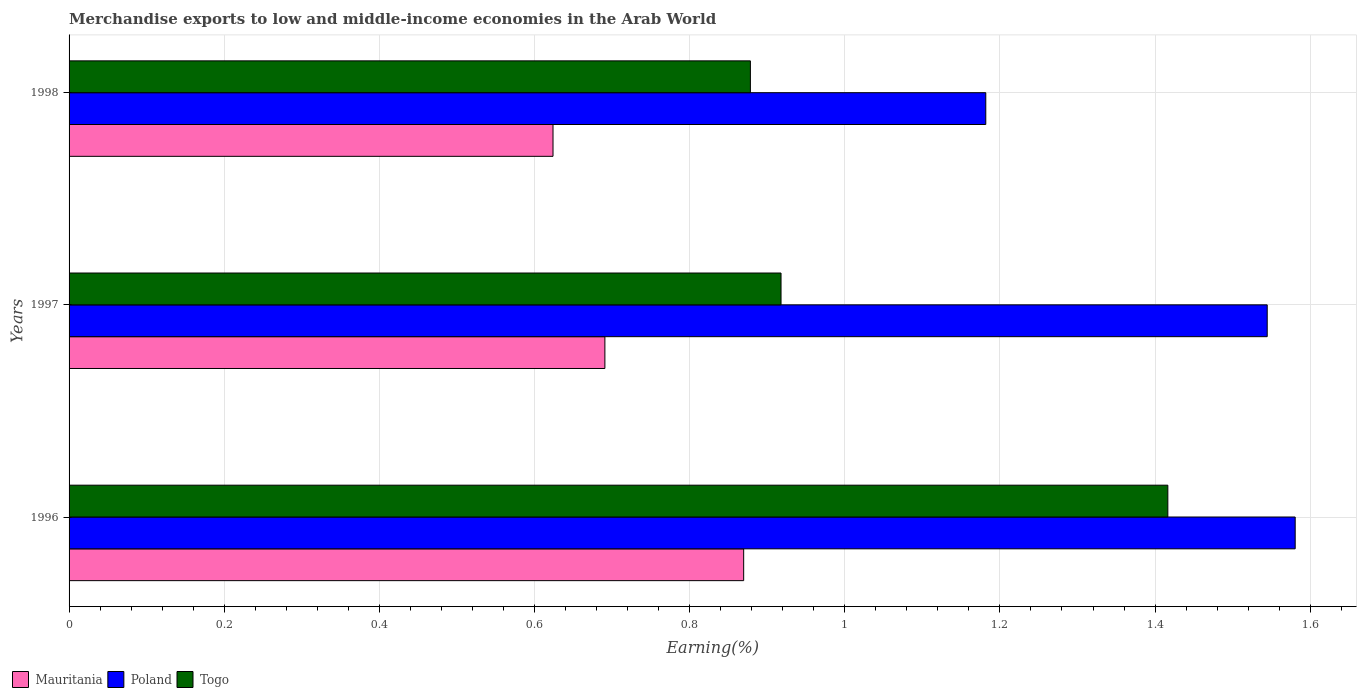How many different coloured bars are there?
Provide a succinct answer. 3. Are the number of bars on each tick of the Y-axis equal?
Provide a succinct answer. Yes. How many bars are there on the 3rd tick from the bottom?
Provide a succinct answer. 3. In how many cases, is the number of bars for a given year not equal to the number of legend labels?
Offer a very short reply. 0. What is the percentage of amount earned from merchandise exports in Mauritania in 1998?
Your response must be concise. 0.62. Across all years, what is the maximum percentage of amount earned from merchandise exports in Mauritania?
Keep it short and to the point. 0.87. Across all years, what is the minimum percentage of amount earned from merchandise exports in Togo?
Keep it short and to the point. 0.88. In which year was the percentage of amount earned from merchandise exports in Mauritania minimum?
Provide a succinct answer. 1998. What is the total percentage of amount earned from merchandise exports in Mauritania in the graph?
Provide a succinct answer. 2.18. What is the difference between the percentage of amount earned from merchandise exports in Mauritania in 1997 and that in 1998?
Provide a short and direct response. 0.07. What is the difference between the percentage of amount earned from merchandise exports in Mauritania in 1996 and the percentage of amount earned from merchandise exports in Poland in 1998?
Keep it short and to the point. -0.31. What is the average percentage of amount earned from merchandise exports in Poland per year?
Provide a succinct answer. 1.44. In the year 1996, what is the difference between the percentage of amount earned from merchandise exports in Togo and percentage of amount earned from merchandise exports in Mauritania?
Offer a very short reply. 0.55. What is the ratio of the percentage of amount earned from merchandise exports in Togo in 1996 to that in 1997?
Offer a very short reply. 1.54. Is the difference between the percentage of amount earned from merchandise exports in Togo in 1997 and 1998 greater than the difference between the percentage of amount earned from merchandise exports in Mauritania in 1997 and 1998?
Ensure brevity in your answer.  No. What is the difference between the highest and the second highest percentage of amount earned from merchandise exports in Poland?
Offer a terse response. 0.04. What is the difference between the highest and the lowest percentage of amount earned from merchandise exports in Mauritania?
Your answer should be very brief. 0.25. In how many years, is the percentage of amount earned from merchandise exports in Mauritania greater than the average percentage of amount earned from merchandise exports in Mauritania taken over all years?
Make the answer very short. 1. What does the 3rd bar from the top in 1998 represents?
Your answer should be compact. Mauritania. What does the 3rd bar from the bottom in 1998 represents?
Your answer should be very brief. Togo. Is it the case that in every year, the sum of the percentage of amount earned from merchandise exports in Poland and percentage of amount earned from merchandise exports in Mauritania is greater than the percentage of amount earned from merchandise exports in Togo?
Give a very brief answer. Yes. Does the graph contain grids?
Give a very brief answer. Yes. How many legend labels are there?
Your answer should be compact. 3. How are the legend labels stacked?
Offer a very short reply. Horizontal. What is the title of the graph?
Offer a very short reply. Merchandise exports to low and middle-income economies in the Arab World. What is the label or title of the X-axis?
Give a very brief answer. Earning(%). What is the Earning(%) of Mauritania in 1996?
Your answer should be very brief. 0.87. What is the Earning(%) of Poland in 1996?
Offer a terse response. 1.58. What is the Earning(%) of Togo in 1996?
Give a very brief answer. 1.42. What is the Earning(%) of Mauritania in 1997?
Your response must be concise. 0.69. What is the Earning(%) in Poland in 1997?
Make the answer very short. 1.54. What is the Earning(%) in Togo in 1997?
Offer a very short reply. 0.92. What is the Earning(%) in Mauritania in 1998?
Provide a short and direct response. 0.62. What is the Earning(%) in Poland in 1998?
Your response must be concise. 1.18. What is the Earning(%) in Togo in 1998?
Give a very brief answer. 0.88. Across all years, what is the maximum Earning(%) of Mauritania?
Make the answer very short. 0.87. Across all years, what is the maximum Earning(%) in Poland?
Offer a terse response. 1.58. Across all years, what is the maximum Earning(%) in Togo?
Keep it short and to the point. 1.42. Across all years, what is the minimum Earning(%) in Mauritania?
Your answer should be very brief. 0.62. Across all years, what is the minimum Earning(%) in Poland?
Offer a terse response. 1.18. Across all years, what is the minimum Earning(%) in Togo?
Give a very brief answer. 0.88. What is the total Earning(%) of Mauritania in the graph?
Offer a terse response. 2.18. What is the total Earning(%) of Poland in the graph?
Keep it short and to the point. 4.31. What is the total Earning(%) in Togo in the graph?
Provide a succinct answer. 3.21. What is the difference between the Earning(%) in Mauritania in 1996 and that in 1997?
Your answer should be compact. 0.18. What is the difference between the Earning(%) in Poland in 1996 and that in 1997?
Your answer should be compact. 0.04. What is the difference between the Earning(%) of Togo in 1996 and that in 1997?
Provide a short and direct response. 0.5. What is the difference between the Earning(%) in Mauritania in 1996 and that in 1998?
Provide a succinct answer. 0.25. What is the difference between the Earning(%) of Poland in 1996 and that in 1998?
Keep it short and to the point. 0.4. What is the difference between the Earning(%) of Togo in 1996 and that in 1998?
Your response must be concise. 0.54. What is the difference between the Earning(%) of Mauritania in 1997 and that in 1998?
Offer a very short reply. 0.07. What is the difference between the Earning(%) in Poland in 1997 and that in 1998?
Give a very brief answer. 0.36. What is the difference between the Earning(%) in Togo in 1997 and that in 1998?
Your answer should be very brief. 0.04. What is the difference between the Earning(%) of Mauritania in 1996 and the Earning(%) of Poland in 1997?
Provide a succinct answer. -0.67. What is the difference between the Earning(%) of Mauritania in 1996 and the Earning(%) of Togo in 1997?
Offer a terse response. -0.05. What is the difference between the Earning(%) of Poland in 1996 and the Earning(%) of Togo in 1997?
Keep it short and to the point. 0.66. What is the difference between the Earning(%) of Mauritania in 1996 and the Earning(%) of Poland in 1998?
Your answer should be compact. -0.31. What is the difference between the Earning(%) in Mauritania in 1996 and the Earning(%) in Togo in 1998?
Offer a very short reply. -0.01. What is the difference between the Earning(%) in Poland in 1996 and the Earning(%) in Togo in 1998?
Offer a very short reply. 0.7. What is the difference between the Earning(%) in Mauritania in 1997 and the Earning(%) in Poland in 1998?
Give a very brief answer. -0.49. What is the difference between the Earning(%) of Mauritania in 1997 and the Earning(%) of Togo in 1998?
Provide a succinct answer. -0.19. What is the difference between the Earning(%) of Poland in 1997 and the Earning(%) of Togo in 1998?
Provide a succinct answer. 0.67. What is the average Earning(%) of Mauritania per year?
Your answer should be compact. 0.73. What is the average Earning(%) in Poland per year?
Your answer should be compact. 1.44. What is the average Earning(%) of Togo per year?
Your response must be concise. 1.07. In the year 1996, what is the difference between the Earning(%) in Mauritania and Earning(%) in Poland?
Provide a succinct answer. -0.71. In the year 1996, what is the difference between the Earning(%) of Mauritania and Earning(%) of Togo?
Ensure brevity in your answer.  -0.55. In the year 1996, what is the difference between the Earning(%) of Poland and Earning(%) of Togo?
Your answer should be compact. 0.16. In the year 1997, what is the difference between the Earning(%) in Mauritania and Earning(%) in Poland?
Provide a succinct answer. -0.85. In the year 1997, what is the difference between the Earning(%) in Mauritania and Earning(%) in Togo?
Offer a terse response. -0.23. In the year 1997, what is the difference between the Earning(%) in Poland and Earning(%) in Togo?
Offer a very short reply. 0.63. In the year 1998, what is the difference between the Earning(%) of Mauritania and Earning(%) of Poland?
Your response must be concise. -0.56. In the year 1998, what is the difference between the Earning(%) in Mauritania and Earning(%) in Togo?
Keep it short and to the point. -0.25. In the year 1998, what is the difference between the Earning(%) of Poland and Earning(%) of Togo?
Make the answer very short. 0.3. What is the ratio of the Earning(%) of Mauritania in 1996 to that in 1997?
Make the answer very short. 1.26. What is the ratio of the Earning(%) in Poland in 1996 to that in 1997?
Offer a terse response. 1.02. What is the ratio of the Earning(%) in Togo in 1996 to that in 1997?
Your answer should be very brief. 1.54. What is the ratio of the Earning(%) in Mauritania in 1996 to that in 1998?
Give a very brief answer. 1.39. What is the ratio of the Earning(%) in Poland in 1996 to that in 1998?
Offer a terse response. 1.34. What is the ratio of the Earning(%) in Togo in 1996 to that in 1998?
Your response must be concise. 1.61. What is the ratio of the Earning(%) of Mauritania in 1997 to that in 1998?
Offer a very short reply. 1.11. What is the ratio of the Earning(%) in Poland in 1997 to that in 1998?
Give a very brief answer. 1.31. What is the ratio of the Earning(%) of Togo in 1997 to that in 1998?
Keep it short and to the point. 1.04. What is the difference between the highest and the second highest Earning(%) in Mauritania?
Ensure brevity in your answer.  0.18. What is the difference between the highest and the second highest Earning(%) in Poland?
Ensure brevity in your answer.  0.04. What is the difference between the highest and the second highest Earning(%) in Togo?
Offer a very short reply. 0.5. What is the difference between the highest and the lowest Earning(%) in Mauritania?
Provide a short and direct response. 0.25. What is the difference between the highest and the lowest Earning(%) of Poland?
Make the answer very short. 0.4. What is the difference between the highest and the lowest Earning(%) of Togo?
Ensure brevity in your answer.  0.54. 